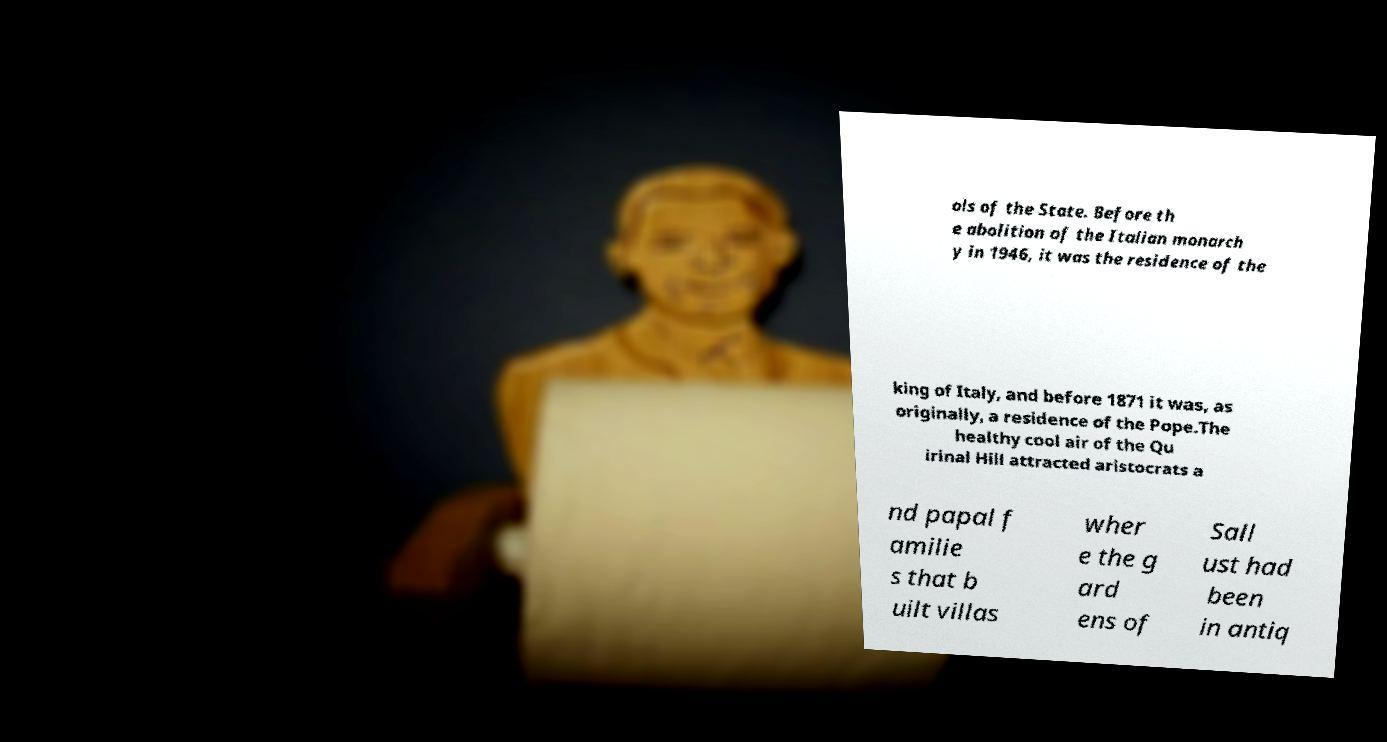I need the written content from this picture converted into text. Can you do that? ols of the State. Before th e abolition of the Italian monarch y in 1946, it was the residence of the king of Italy, and before 1871 it was, as originally, a residence of the Pope.The healthy cool air of the Qu irinal Hill attracted aristocrats a nd papal f amilie s that b uilt villas wher e the g ard ens of Sall ust had been in antiq 